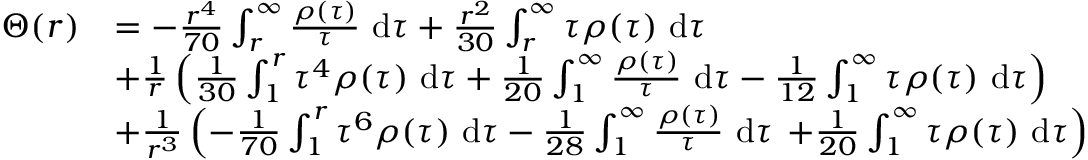<formula> <loc_0><loc_0><loc_500><loc_500>\begin{array} { r l } { \Theta ( r ) } & { = - \frac { r ^ { 4 } } { 7 0 } \int _ { r } ^ { \infty } \frac { \rho ( \tau ) } { \tau } d \tau + \frac { r ^ { 2 } } { 3 0 } \int _ { r } ^ { \infty } \tau \rho ( \tau ) d \tau } \\ & { + \frac { 1 } { r } \left ( \frac { 1 } { 3 0 } \int _ { 1 } ^ { r } \tau ^ { 4 } \rho ( \tau ) d \tau + \frac { 1 } { 2 0 } \int _ { 1 } ^ { \infty } \frac { \rho ( \tau ) } { \tau } d \tau - \frac { 1 } { 1 2 } \int _ { 1 } ^ { \infty } \tau \rho ( \tau ) d \tau \right ) } \\ & { + \frac { 1 } { r ^ { 3 } } \left ( - \frac { 1 } { 7 0 } \int _ { 1 } ^ { r } \tau ^ { 6 } \rho ( \tau ) d \tau - \frac { 1 } { 2 8 } \int _ { 1 } ^ { \infty } \frac { \rho ( \tau ) } { \tau } d \tau + \frac { 1 } { 2 0 } \int _ { 1 } ^ { \infty } \tau \rho ( \tau ) d \tau \right ) } \end{array}</formula> 